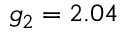<formula> <loc_0><loc_0><loc_500><loc_500>g _ { 2 } = 2 . 0 4</formula> 